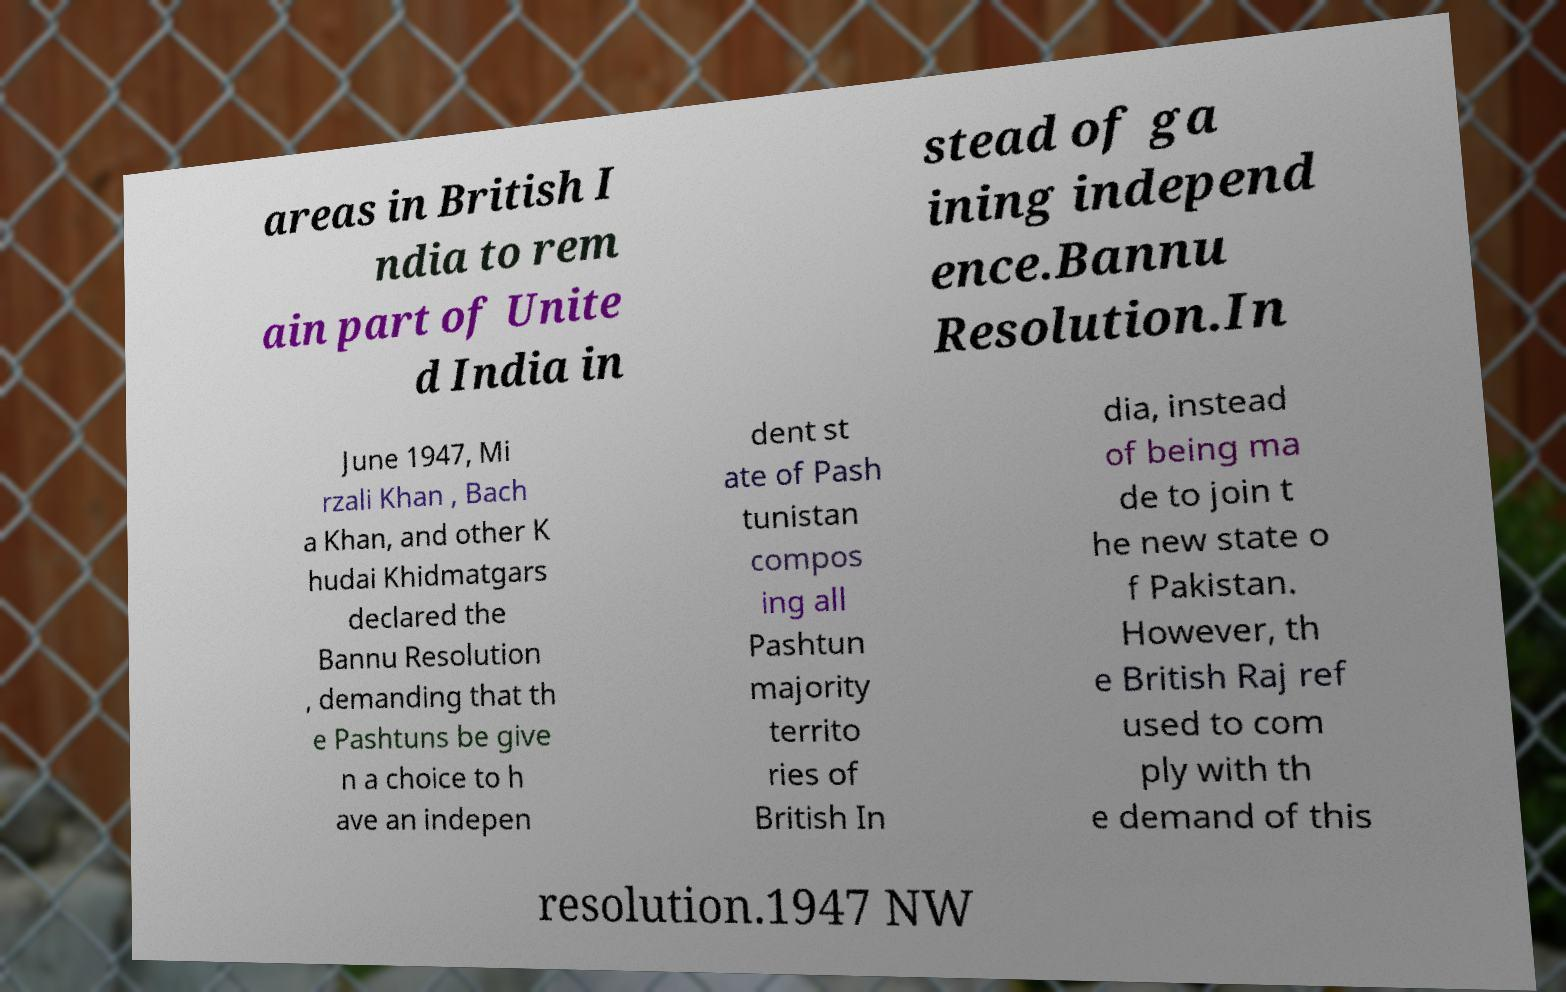There's text embedded in this image that I need extracted. Can you transcribe it verbatim? areas in British I ndia to rem ain part of Unite d India in stead of ga ining independ ence.Bannu Resolution.In June 1947, Mi rzali Khan , Bach a Khan, and other K hudai Khidmatgars declared the Bannu Resolution , demanding that th e Pashtuns be give n a choice to h ave an indepen dent st ate of Pash tunistan compos ing all Pashtun majority territo ries of British In dia, instead of being ma de to join t he new state o f Pakistan. However, th e British Raj ref used to com ply with th e demand of this resolution.1947 NW 